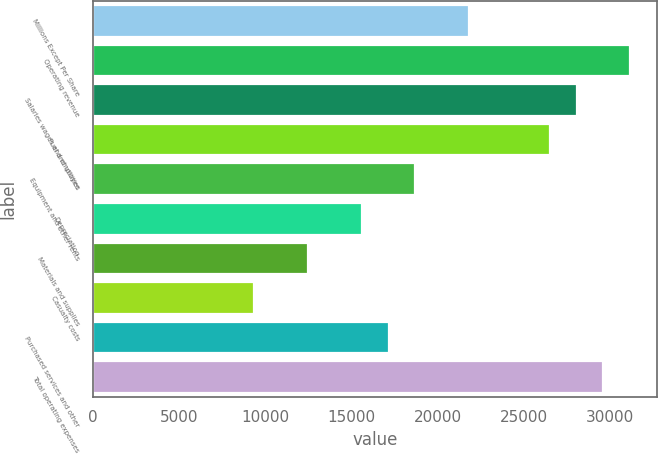Convert chart to OTSL. <chart><loc_0><loc_0><loc_500><loc_500><bar_chart><fcel>Millions Except Per Share<fcel>Operating revenue<fcel>Salaries wages and employee<fcel>Fuel and utilities<fcel>Equipment and other rents<fcel>Depreciation<fcel>Materials and supplies<fcel>Casualty costs<fcel>Purchased services and other<fcel>Total operating expenses<nl><fcel>21808.7<fcel>31154.8<fcel>28039.4<fcel>26481.8<fcel>18693.4<fcel>15578<fcel>12462.6<fcel>9347.28<fcel>17135.7<fcel>29597.1<nl></chart> 